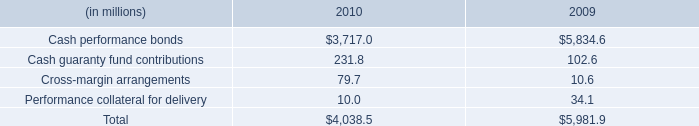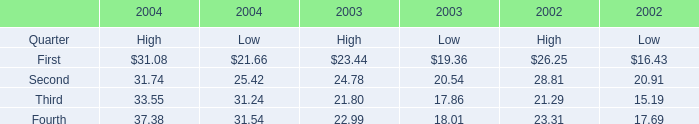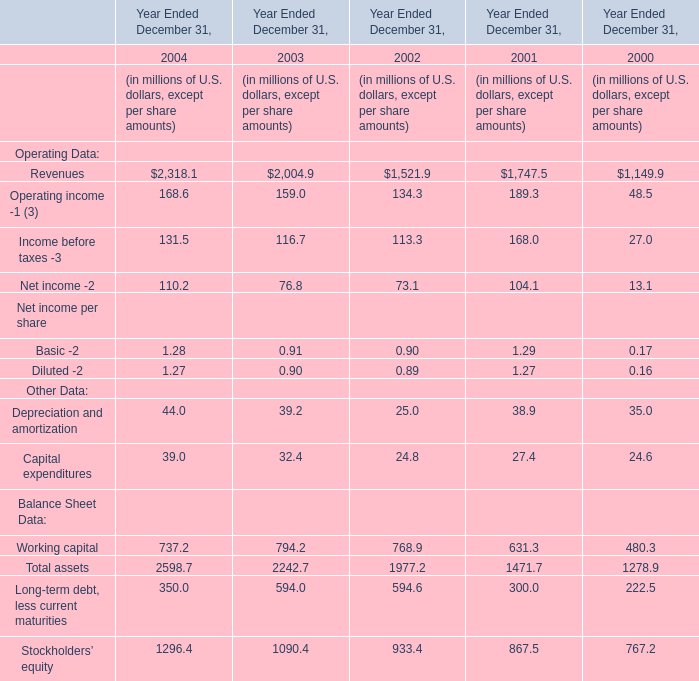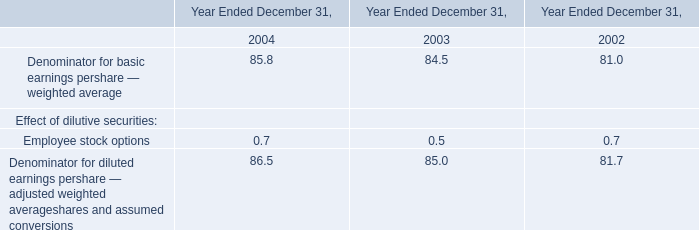What was the amount of the Revenues in 2000? (in million) 
Answer: 1149.9. 